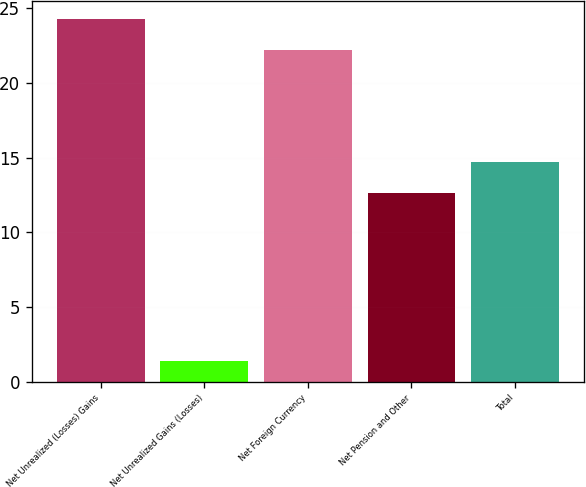<chart> <loc_0><loc_0><loc_500><loc_500><bar_chart><fcel>Net Unrealized (Losses) Gains<fcel>Net Unrealized Gains (Losses)<fcel>Net Foreign Currency<fcel>Net Pension and Other<fcel>Total<nl><fcel>24.29<fcel>1.4<fcel>22.2<fcel>12.6<fcel>14.69<nl></chart> 